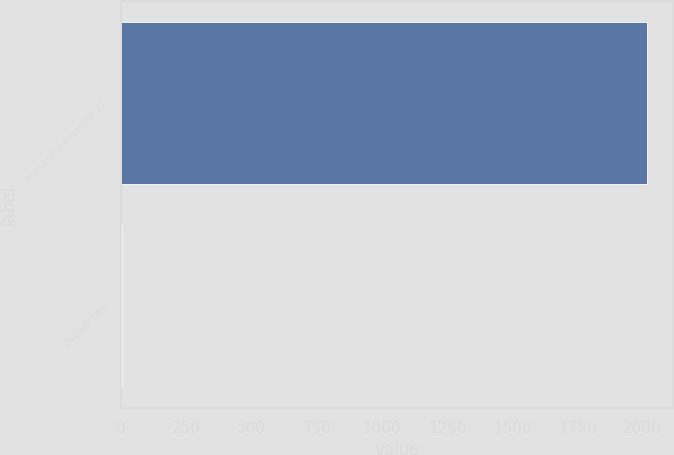Convert chart to OTSL. <chart><loc_0><loc_0><loc_500><loc_500><bar_chart><fcel>Years ended December 31<fcel>Discount rate<nl><fcel>2017<fcel>4.05<nl></chart> 